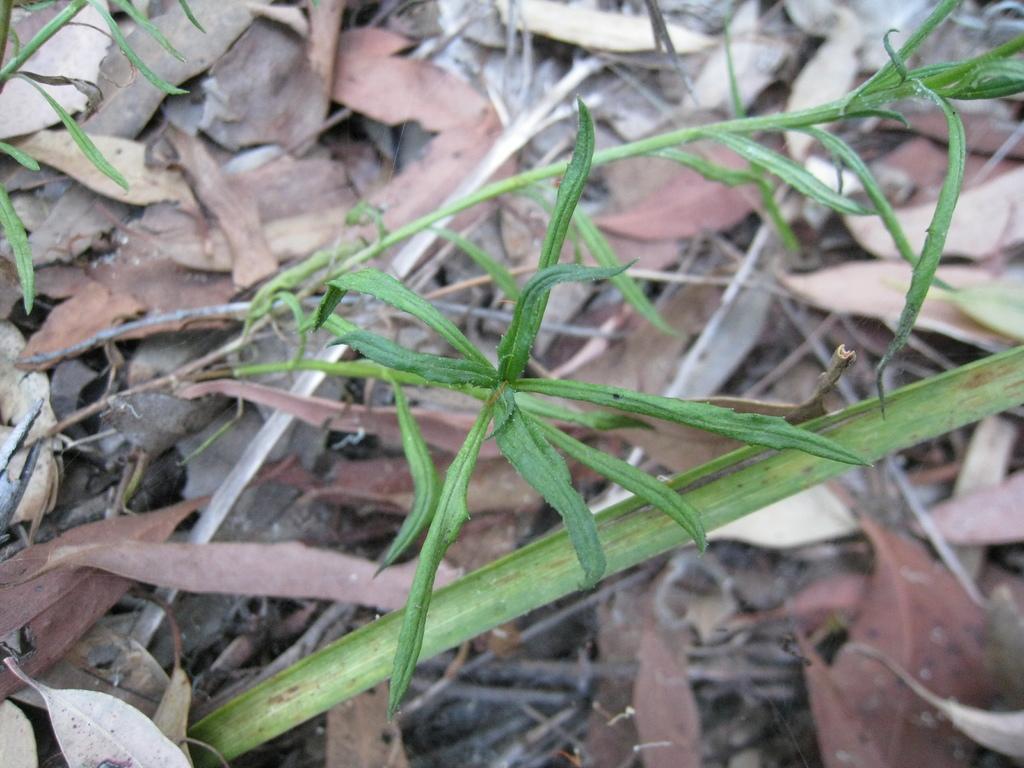Can you describe this image briefly? In this picture we can see a plant here, at the bottom there are some leaves. 